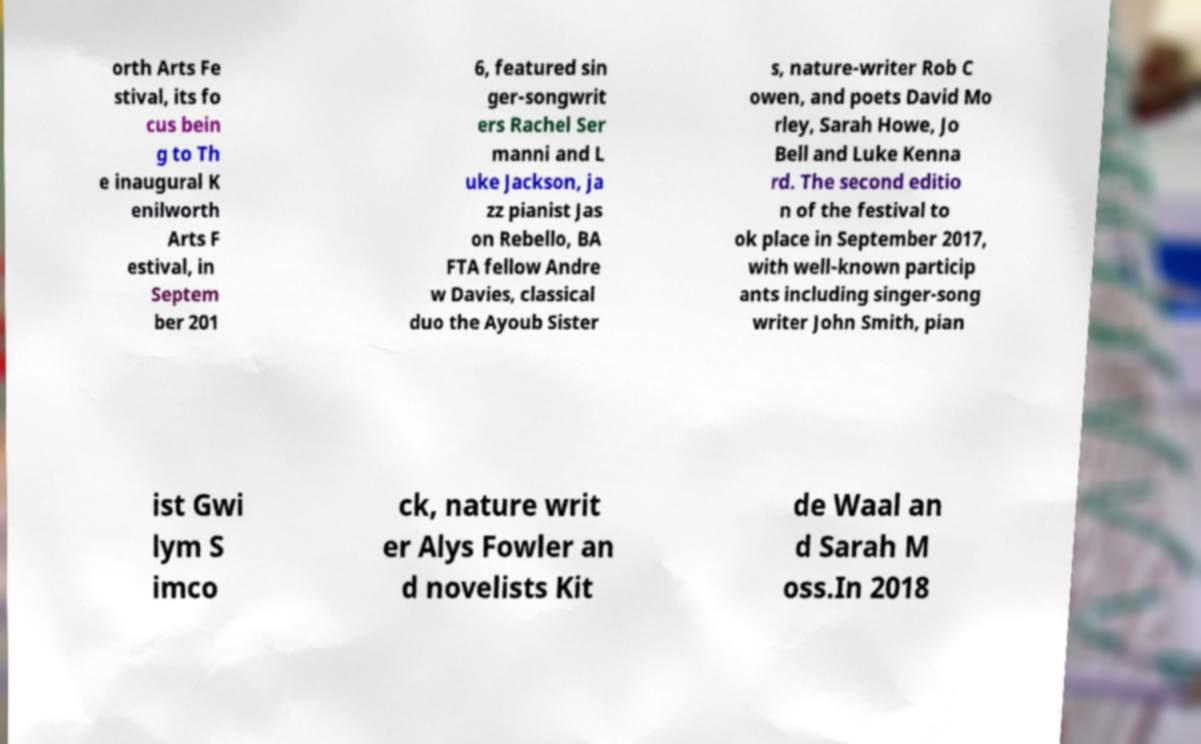Please read and relay the text visible in this image. What does it say? orth Arts Fe stival, its fo cus bein g to Th e inaugural K enilworth Arts F estival, in Septem ber 201 6, featured sin ger-songwrit ers Rachel Ser manni and L uke Jackson, ja zz pianist Jas on Rebello, BA FTA fellow Andre w Davies, classical duo the Ayoub Sister s, nature-writer Rob C owen, and poets David Mo rley, Sarah Howe, Jo Bell and Luke Kenna rd. The second editio n of the festival to ok place in September 2017, with well-known particip ants including singer-song writer John Smith, pian ist Gwi lym S imco ck, nature writ er Alys Fowler an d novelists Kit de Waal an d Sarah M oss.In 2018 